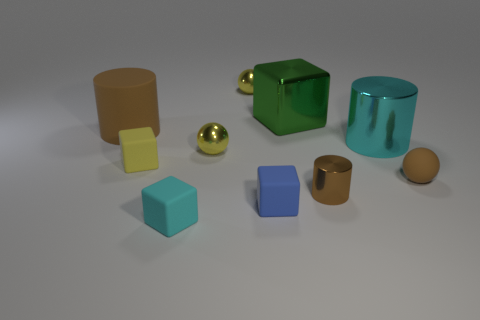Subtract all blocks. How many objects are left? 6 Subtract all big gray things. Subtract all large rubber things. How many objects are left? 9 Add 4 small matte objects. How many small matte objects are left? 8 Add 8 tiny green metal objects. How many tiny green metal objects exist? 8 Subtract 1 yellow blocks. How many objects are left? 9 